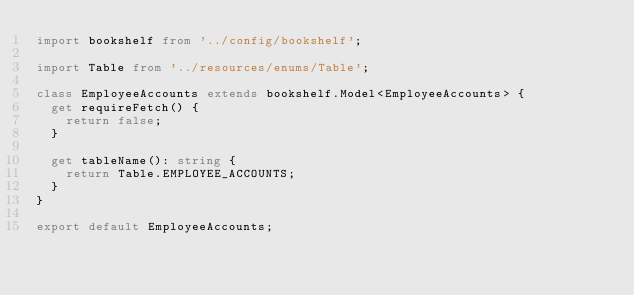Convert code to text. <code><loc_0><loc_0><loc_500><loc_500><_TypeScript_>import bookshelf from '../config/bookshelf';

import Table from '../resources/enums/Table';

class EmployeeAccounts extends bookshelf.Model<EmployeeAccounts> {
  get requireFetch() {
    return false;
  }

  get tableName(): string {
    return Table.EMPLOYEE_ACCOUNTS;
  }
}

export default EmployeeAccounts;
</code> 